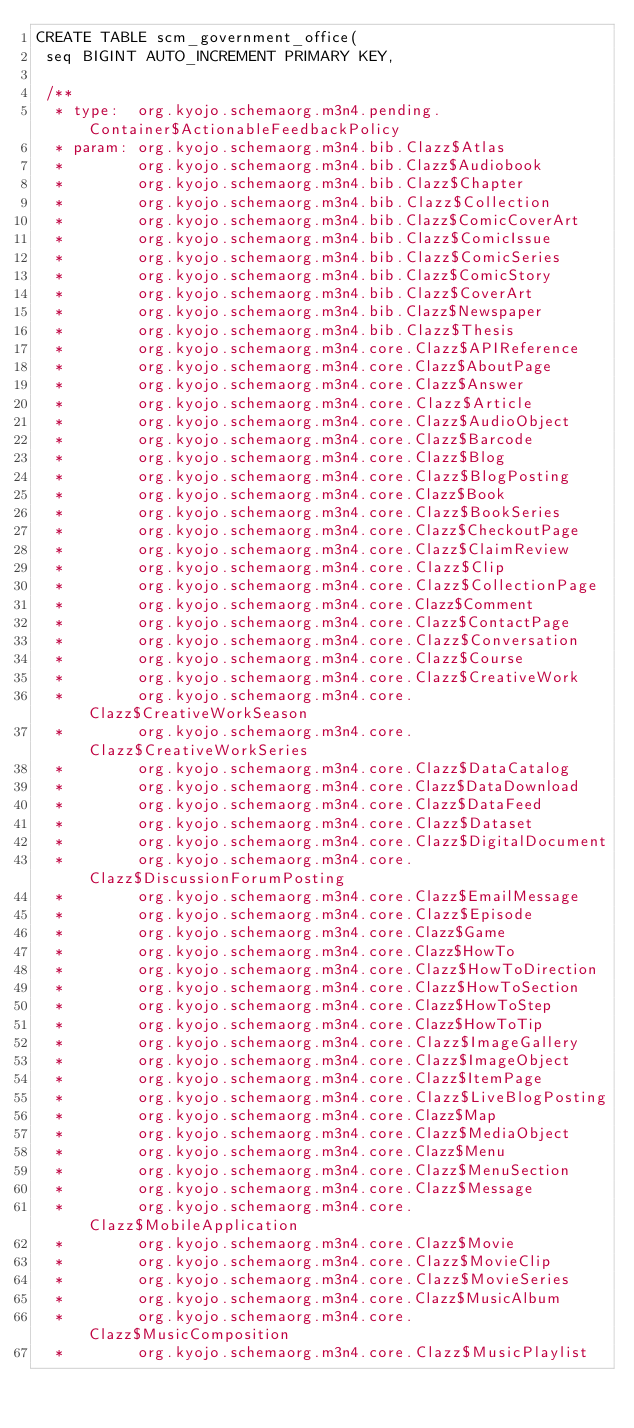Convert code to text. <code><loc_0><loc_0><loc_500><loc_500><_SQL_>CREATE TABLE scm_government_office(
 seq BIGINT AUTO_INCREMENT PRIMARY KEY,

 /**
  * type:  org.kyojo.schemaorg.m3n4.pending.Container$ActionableFeedbackPolicy
  * param: org.kyojo.schemaorg.m3n4.bib.Clazz$Atlas
  *        org.kyojo.schemaorg.m3n4.bib.Clazz$Audiobook
  *        org.kyojo.schemaorg.m3n4.bib.Clazz$Chapter
  *        org.kyojo.schemaorg.m3n4.bib.Clazz$Collection
  *        org.kyojo.schemaorg.m3n4.bib.Clazz$ComicCoverArt
  *        org.kyojo.schemaorg.m3n4.bib.Clazz$ComicIssue
  *        org.kyojo.schemaorg.m3n4.bib.Clazz$ComicSeries
  *        org.kyojo.schemaorg.m3n4.bib.Clazz$ComicStory
  *        org.kyojo.schemaorg.m3n4.bib.Clazz$CoverArt
  *        org.kyojo.schemaorg.m3n4.bib.Clazz$Newspaper
  *        org.kyojo.schemaorg.m3n4.bib.Clazz$Thesis
  *        org.kyojo.schemaorg.m3n4.core.Clazz$APIReference
  *        org.kyojo.schemaorg.m3n4.core.Clazz$AboutPage
  *        org.kyojo.schemaorg.m3n4.core.Clazz$Answer
  *        org.kyojo.schemaorg.m3n4.core.Clazz$Article
  *        org.kyojo.schemaorg.m3n4.core.Clazz$AudioObject
  *        org.kyojo.schemaorg.m3n4.core.Clazz$Barcode
  *        org.kyojo.schemaorg.m3n4.core.Clazz$Blog
  *        org.kyojo.schemaorg.m3n4.core.Clazz$BlogPosting
  *        org.kyojo.schemaorg.m3n4.core.Clazz$Book
  *        org.kyojo.schemaorg.m3n4.core.Clazz$BookSeries
  *        org.kyojo.schemaorg.m3n4.core.Clazz$CheckoutPage
  *        org.kyojo.schemaorg.m3n4.core.Clazz$ClaimReview
  *        org.kyojo.schemaorg.m3n4.core.Clazz$Clip
  *        org.kyojo.schemaorg.m3n4.core.Clazz$CollectionPage
  *        org.kyojo.schemaorg.m3n4.core.Clazz$Comment
  *        org.kyojo.schemaorg.m3n4.core.Clazz$ContactPage
  *        org.kyojo.schemaorg.m3n4.core.Clazz$Conversation
  *        org.kyojo.schemaorg.m3n4.core.Clazz$Course
  *        org.kyojo.schemaorg.m3n4.core.Clazz$CreativeWork
  *        org.kyojo.schemaorg.m3n4.core.Clazz$CreativeWorkSeason
  *        org.kyojo.schemaorg.m3n4.core.Clazz$CreativeWorkSeries
  *        org.kyojo.schemaorg.m3n4.core.Clazz$DataCatalog
  *        org.kyojo.schemaorg.m3n4.core.Clazz$DataDownload
  *        org.kyojo.schemaorg.m3n4.core.Clazz$DataFeed
  *        org.kyojo.schemaorg.m3n4.core.Clazz$Dataset
  *        org.kyojo.schemaorg.m3n4.core.Clazz$DigitalDocument
  *        org.kyojo.schemaorg.m3n4.core.Clazz$DiscussionForumPosting
  *        org.kyojo.schemaorg.m3n4.core.Clazz$EmailMessage
  *        org.kyojo.schemaorg.m3n4.core.Clazz$Episode
  *        org.kyojo.schemaorg.m3n4.core.Clazz$Game
  *        org.kyojo.schemaorg.m3n4.core.Clazz$HowTo
  *        org.kyojo.schemaorg.m3n4.core.Clazz$HowToDirection
  *        org.kyojo.schemaorg.m3n4.core.Clazz$HowToSection
  *        org.kyojo.schemaorg.m3n4.core.Clazz$HowToStep
  *        org.kyojo.schemaorg.m3n4.core.Clazz$HowToTip
  *        org.kyojo.schemaorg.m3n4.core.Clazz$ImageGallery
  *        org.kyojo.schemaorg.m3n4.core.Clazz$ImageObject
  *        org.kyojo.schemaorg.m3n4.core.Clazz$ItemPage
  *        org.kyojo.schemaorg.m3n4.core.Clazz$LiveBlogPosting
  *        org.kyojo.schemaorg.m3n4.core.Clazz$Map
  *        org.kyojo.schemaorg.m3n4.core.Clazz$MediaObject
  *        org.kyojo.schemaorg.m3n4.core.Clazz$Menu
  *        org.kyojo.schemaorg.m3n4.core.Clazz$MenuSection
  *        org.kyojo.schemaorg.m3n4.core.Clazz$Message
  *        org.kyojo.schemaorg.m3n4.core.Clazz$MobileApplication
  *        org.kyojo.schemaorg.m3n4.core.Clazz$Movie
  *        org.kyojo.schemaorg.m3n4.core.Clazz$MovieClip
  *        org.kyojo.schemaorg.m3n4.core.Clazz$MovieSeries
  *        org.kyojo.schemaorg.m3n4.core.Clazz$MusicAlbum
  *        org.kyojo.schemaorg.m3n4.core.Clazz$MusicComposition
  *        org.kyojo.schemaorg.m3n4.core.Clazz$MusicPlaylist</code> 